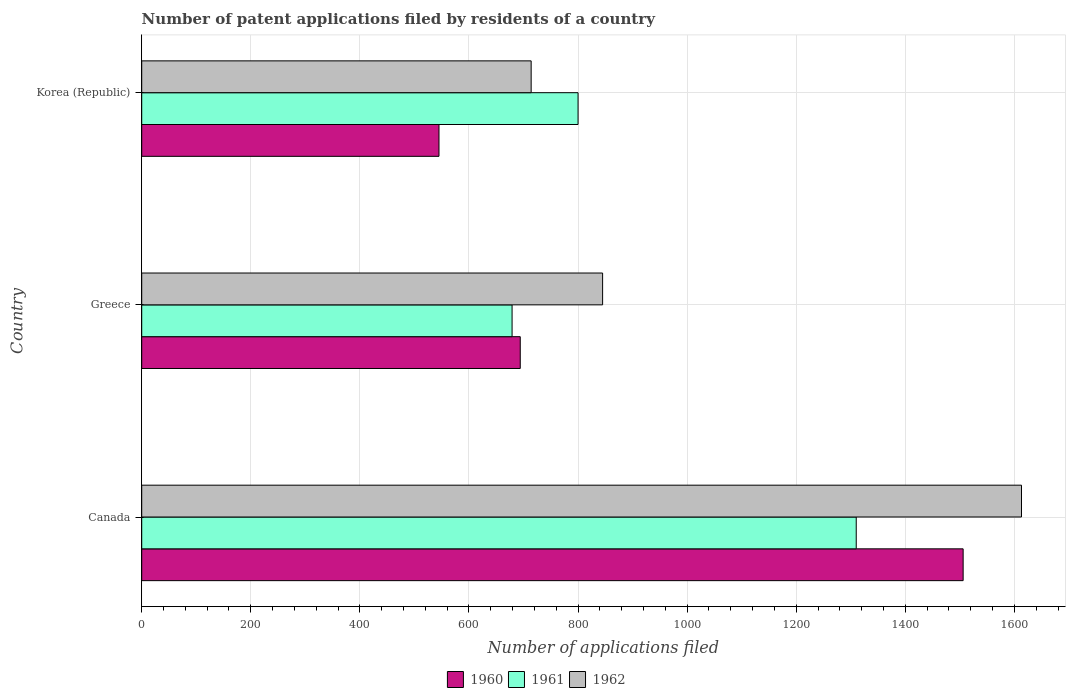How many different coloured bars are there?
Keep it short and to the point. 3. Are the number of bars per tick equal to the number of legend labels?
Ensure brevity in your answer.  Yes. How many bars are there on the 1st tick from the top?
Keep it short and to the point. 3. What is the number of applications filed in 1961 in Canada?
Your answer should be compact. 1310. Across all countries, what is the maximum number of applications filed in 1962?
Provide a succinct answer. 1613. Across all countries, what is the minimum number of applications filed in 1961?
Offer a very short reply. 679. In which country was the number of applications filed in 1960 maximum?
Provide a short and direct response. Canada. In which country was the number of applications filed in 1962 minimum?
Keep it short and to the point. Korea (Republic). What is the total number of applications filed in 1962 in the graph?
Make the answer very short. 3172. What is the difference between the number of applications filed in 1962 in Greece and that in Korea (Republic)?
Provide a succinct answer. 131. What is the difference between the number of applications filed in 1961 in Greece and the number of applications filed in 1962 in Korea (Republic)?
Offer a terse response. -35. What is the average number of applications filed in 1961 per country?
Keep it short and to the point. 929.67. What is the difference between the number of applications filed in 1961 and number of applications filed in 1960 in Canada?
Provide a succinct answer. -196. In how many countries, is the number of applications filed in 1962 greater than 440 ?
Provide a short and direct response. 3. What is the ratio of the number of applications filed in 1960 in Canada to that in Korea (Republic)?
Give a very brief answer. 2.76. Is the number of applications filed in 1962 in Greece less than that in Korea (Republic)?
Make the answer very short. No. Is the difference between the number of applications filed in 1961 in Greece and Korea (Republic) greater than the difference between the number of applications filed in 1960 in Greece and Korea (Republic)?
Your answer should be very brief. No. What is the difference between the highest and the second highest number of applications filed in 1961?
Your response must be concise. 510. What is the difference between the highest and the lowest number of applications filed in 1961?
Provide a succinct answer. 631. What does the 3rd bar from the top in Greece represents?
Provide a short and direct response. 1960. What does the 3rd bar from the bottom in Korea (Republic) represents?
Give a very brief answer. 1962. Is it the case that in every country, the sum of the number of applications filed in 1960 and number of applications filed in 1961 is greater than the number of applications filed in 1962?
Ensure brevity in your answer.  Yes. How many bars are there?
Provide a succinct answer. 9. How many countries are there in the graph?
Offer a terse response. 3. What is the difference between two consecutive major ticks on the X-axis?
Give a very brief answer. 200. Does the graph contain any zero values?
Give a very brief answer. No. Does the graph contain grids?
Make the answer very short. Yes. Where does the legend appear in the graph?
Ensure brevity in your answer.  Bottom center. How are the legend labels stacked?
Ensure brevity in your answer.  Horizontal. What is the title of the graph?
Provide a short and direct response. Number of patent applications filed by residents of a country. Does "1961" appear as one of the legend labels in the graph?
Offer a very short reply. Yes. What is the label or title of the X-axis?
Give a very brief answer. Number of applications filed. What is the label or title of the Y-axis?
Keep it short and to the point. Country. What is the Number of applications filed in 1960 in Canada?
Offer a very short reply. 1506. What is the Number of applications filed in 1961 in Canada?
Offer a very short reply. 1310. What is the Number of applications filed in 1962 in Canada?
Give a very brief answer. 1613. What is the Number of applications filed of 1960 in Greece?
Provide a short and direct response. 694. What is the Number of applications filed of 1961 in Greece?
Your response must be concise. 679. What is the Number of applications filed in 1962 in Greece?
Provide a succinct answer. 845. What is the Number of applications filed of 1960 in Korea (Republic)?
Keep it short and to the point. 545. What is the Number of applications filed of 1961 in Korea (Republic)?
Offer a terse response. 800. What is the Number of applications filed of 1962 in Korea (Republic)?
Your answer should be very brief. 714. Across all countries, what is the maximum Number of applications filed in 1960?
Make the answer very short. 1506. Across all countries, what is the maximum Number of applications filed of 1961?
Your answer should be compact. 1310. Across all countries, what is the maximum Number of applications filed of 1962?
Make the answer very short. 1613. Across all countries, what is the minimum Number of applications filed of 1960?
Make the answer very short. 545. Across all countries, what is the minimum Number of applications filed in 1961?
Make the answer very short. 679. Across all countries, what is the minimum Number of applications filed of 1962?
Make the answer very short. 714. What is the total Number of applications filed of 1960 in the graph?
Keep it short and to the point. 2745. What is the total Number of applications filed of 1961 in the graph?
Make the answer very short. 2789. What is the total Number of applications filed of 1962 in the graph?
Keep it short and to the point. 3172. What is the difference between the Number of applications filed in 1960 in Canada and that in Greece?
Provide a short and direct response. 812. What is the difference between the Number of applications filed of 1961 in Canada and that in Greece?
Offer a terse response. 631. What is the difference between the Number of applications filed of 1962 in Canada and that in Greece?
Ensure brevity in your answer.  768. What is the difference between the Number of applications filed of 1960 in Canada and that in Korea (Republic)?
Make the answer very short. 961. What is the difference between the Number of applications filed of 1961 in Canada and that in Korea (Republic)?
Your answer should be very brief. 510. What is the difference between the Number of applications filed of 1962 in Canada and that in Korea (Republic)?
Your answer should be compact. 899. What is the difference between the Number of applications filed of 1960 in Greece and that in Korea (Republic)?
Your answer should be very brief. 149. What is the difference between the Number of applications filed of 1961 in Greece and that in Korea (Republic)?
Give a very brief answer. -121. What is the difference between the Number of applications filed in 1962 in Greece and that in Korea (Republic)?
Provide a succinct answer. 131. What is the difference between the Number of applications filed of 1960 in Canada and the Number of applications filed of 1961 in Greece?
Give a very brief answer. 827. What is the difference between the Number of applications filed of 1960 in Canada and the Number of applications filed of 1962 in Greece?
Your answer should be very brief. 661. What is the difference between the Number of applications filed in 1961 in Canada and the Number of applications filed in 1962 in Greece?
Give a very brief answer. 465. What is the difference between the Number of applications filed of 1960 in Canada and the Number of applications filed of 1961 in Korea (Republic)?
Your answer should be very brief. 706. What is the difference between the Number of applications filed in 1960 in Canada and the Number of applications filed in 1962 in Korea (Republic)?
Make the answer very short. 792. What is the difference between the Number of applications filed of 1961 in Canada and the Number of applications filed of 1962 in Korea (Republic)?
Make the answer very short. 596. What is the difference between the Number of applications filed of 1960 in Greece and the Number of applications filed of 1961 in Korea (Republic)?
Make the answer very short. -106. What is the difference between the Number of applications filed in 1961 in Greece and the Number of applications filed in 1962 in Korea (Republic)?
Make the answer very short. -35. What is the average Number of applications filed of 1960 per country?
Provide a short and direct response. 915. What is the average Number of applications filed of 1961 per country?
Ensure brevity in your answer.  929.67. What is the average Number of applications filed of 1962 per country?
Provide a succinct answer. 1057.33. What is the difference between the Number of applications filed in 1960 and Number of applications filed in 1961 in Canada?
Provide a succinct answer. 196. What is the difference between the Number of applications filed of 1960 and Number of applications filed of 1962 in Canada?
Ensure brevity in your answer.  -107. What is the difference between the Number of applications filed in 1961 and Number of applications filed in 1962 in Canada?
Offer a very short reply. -303. What is the difference between the Number of applications filed of 1960 and Number of applications filed of 1961 in Greece?
Offer a terse response. 15. What is the difference between the Number of applications filed in 1960 and Number of applications filed in 1962 in Greece?
Keep it short and to the point. -151. What is the difference between the Number of applications filed in 1961 and Number of applications filed in 1962 in Greece?
Keep it short and to the point. -166. What is the difference between the Number of applications filed of 1960 and Number of applications filed of 1961 in Korea (Republic)?
Your answer should be very brief. -255. What is the difference between the Number of applications filed of 1960 and Number of applications filed of 1962 in Korea (Republic)?
Offer a very short reply. -169. What is the ratio of the Number of applications filed in 1960 in Canada to that in Greece?
Offer a very short reply. 2.17. What is the ratio of the Number of applications filed of 1961 in Canada to that in Greece?
Make the answer very short. 1.93. What is the ratio of the Number of applications filed of 1962 in Canada to that in Greece?
Provide a short and direct response. 1.91. What is the ratio of the Number of applications filed of 1960 in Canada to that in Korea (Republic)?
Ensure brevity in your answer.  2.76. What is the ratio of the Number of applications filed in 1961 in Canada to that in Korea (Republic)?
Make the answer very short. 1.64. What is the ratio of the Number of applications filed in 1962 in Canada to that in Korea (Republic)?
Make the answer very short. 2.26. What is the ratio of the Number of applications filed in 1960 in Greece to that in Korea (Republic)?
Your response must be concise. 1.27. What is the ratio of the Number of applications filed in 1961 in Greece to that in Korea (Republic)?
Give a very brief answer. 0.85. What is the ratio of the Number of applications filed of 1962 in Greece to that in Korea (Republic)?
Your response must be concise. 1.18. What is the difference between the highest and the second highest Number of applications filed of 1960?
Offer a very short reply. 812. What is the difference between the highest and the second highest Number of applications filed in 1961?
Provide a succinct answer. 510. What is the difference between the highest and the second highest Number of applications filed of 1962?
Provide a succinct answer. 768. What is the difference between the highest and the lowest Number of applications filed of 1960?
Give a very brief answer. 961. What is the difference between the highest and the lowest Number of applications filed in 1961?
Ensure brevity in your answer.  631. What is the difference between the highest and the lowest Number of applications filed in 1962?
Your answer should be very brief. 899. 